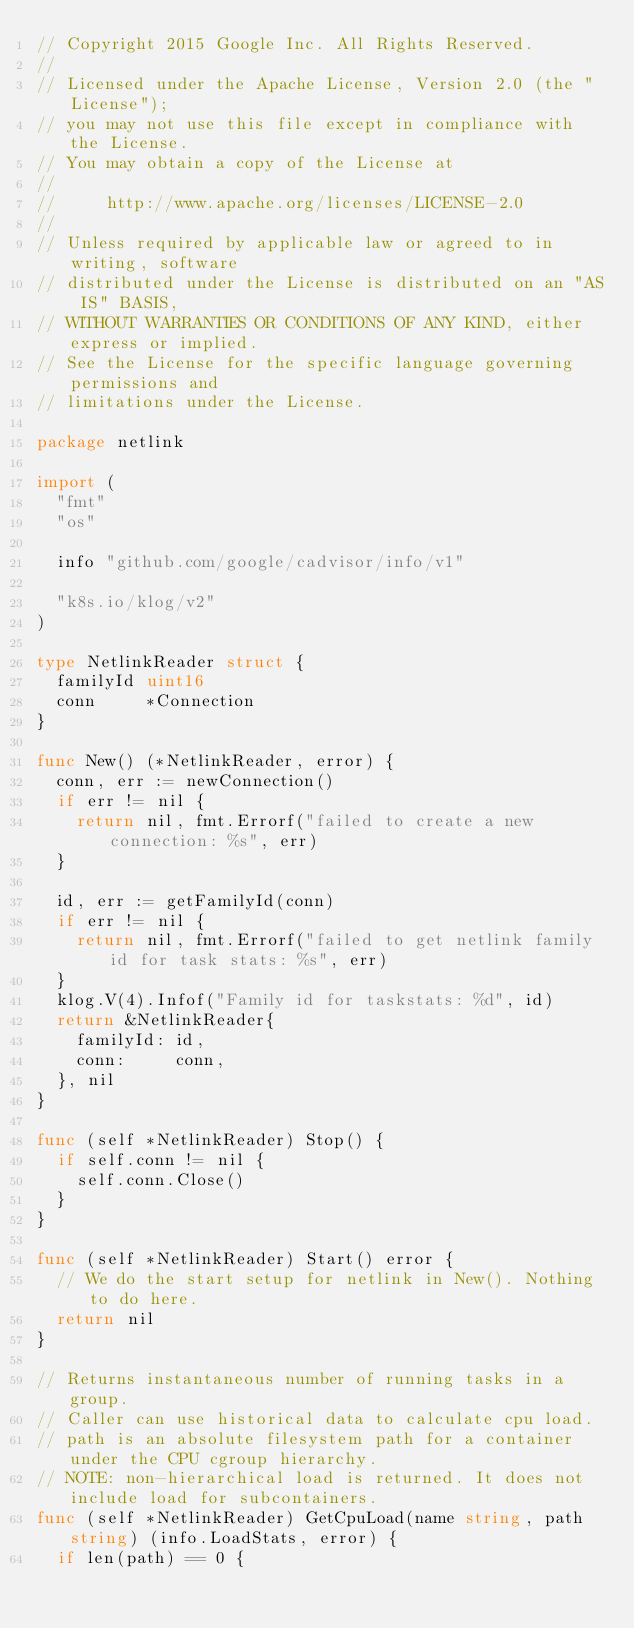Convert code to text. <code><loc_0><loc_0><loc_500><loc_500><_Go_>// Copyright 2015 Google Inc. All Rights Reserved.
//
// Licensed under the Apache License, Version 2.0 (the "License");
// you may not use this file except in compliance with the License.
// You may obtain a copy of the License at
//
//     http://www.apache.org/licenses/LICENSE-2.0
//
// Unless required by applicable law or agreed to in writing, software
// distributed under the License is distributed on an "AS IS" BASIS,
// WITHOUT WARRANTIES OR CONDITIONS OF ANY KIND, either express or implied.
// See the License for the specific language governing permissions and
// limitations under the License.

package netlink

import (
	"fmt"
	"os"

	info "github.com/google/cadvisor/info/v1"

	"k8s.io/klog/v2"
)

type NetlinkReader struct {
	familyId uint16
	conn     *Connection
}

func New() (*NetlinkReader, error) {
	conn, err := newConnection()
	if err != nil {
		return nil, fmt.Errorf("failed to create a new connection: %s", err)
	}

	id, err := getFamilyId(conn)
	if err != nil {
		return nil, fmt.Errorf("failed to get netlink family id for task stats: %s", err)
	}
	klog.V(4).Infof("Family id for taskstats: %d", id)
	return &NetlinkReader{
		familyId: id,
		conn:     conn,
	}, nil
}

func (self *NetlinkReader) Stop() {
	if self.conn != nil {
		self.conn.Close()
	}
}

func (self *NetlinkReader) Start() error {
	// We do the start setup for netlink in New(). Nothing to do here.
	return nil
}

// Returns instantaneous number of running tasks in a group.
// Caller can use historical data to calculate cpu load.
// path is an absolute filesystem path for a container under the CPU cgroup hierarchy.
// NOTE: non-hierarchical load is returned. It does not include load for subcontainers.
func (self *NetlinkReader) GetCpuLoad(name string, path string) (info.LoadStats, error) {
	if len(path) == 0 {</code> 